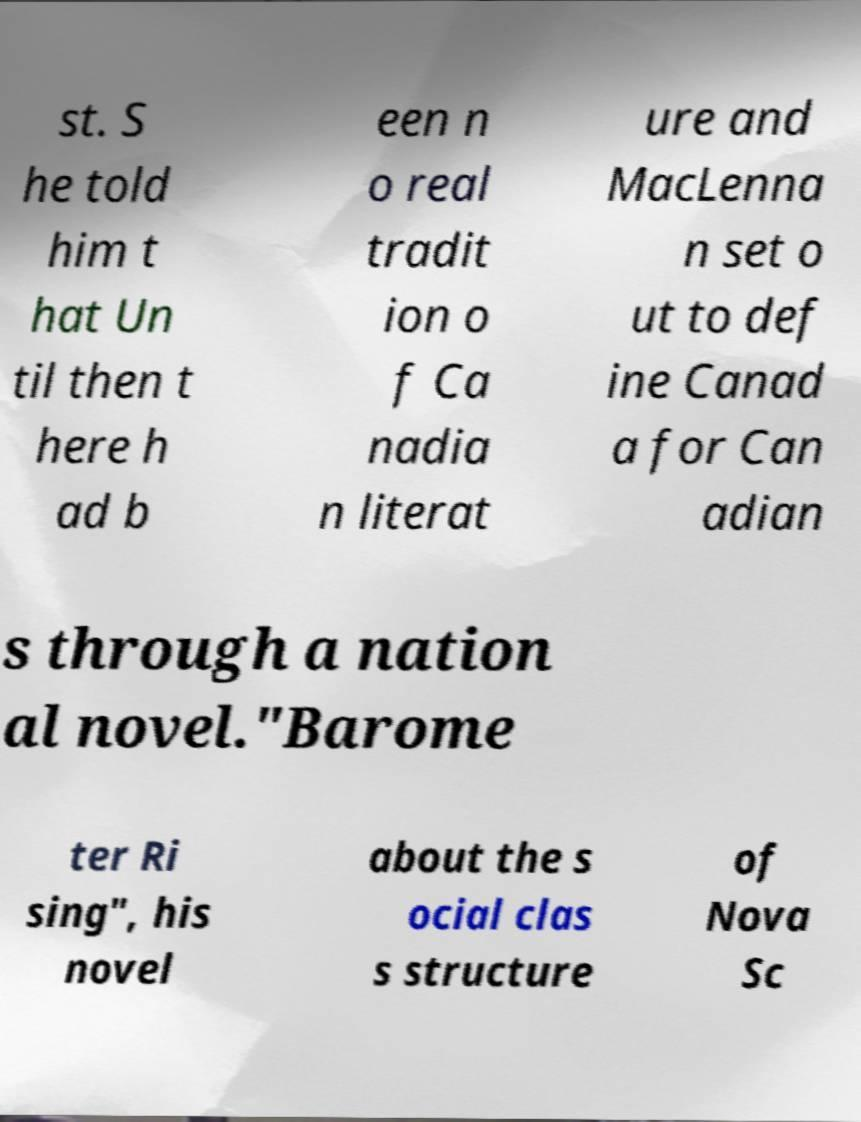Can you accurately transcribe the text from the provided image for me? st. S he told him t hat Un til then t here h ad b een n o real tradit ion o f Ca nadia n literat ure and MacLenna n set o ut to def ine Canad a for Can adian s through a nation al novel."Barome ter Ri sing", his novel about the s ocial clas s structure of Nova Sc 